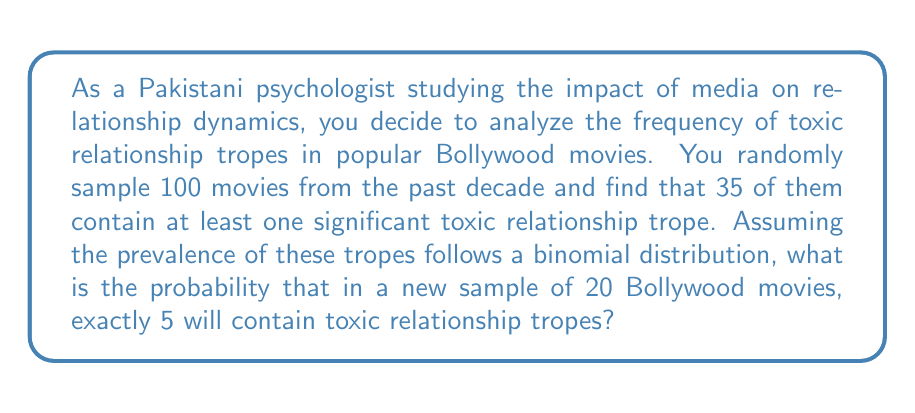Teach me how to tackle this problem. To solve this problem, we need to use the binomial probability distribution formula. The binomial distribution is appropriate here because we have a fixed number of independent trials (watching 20 movies), each with the same probability of success (containing a toxic relationship trope), and we're interested in a specific number of successes.

Let's define our variables:
$n = 20$ (number of movies in the new sample)
$k = 5$ (number of movies we want to contain toxic tropes)
$p = 35/100 = 0.35$ (probability of a movie containing a toxic trope, based on the initial sample)

The binomial probability formula is:

$$P(X = k) = \binom{n}{k} p^k (1-p)^{n-k}$$

Where $\binom{n}{k}$ is the binomial coefficient, calculated as:

$$\binom{n}{k} = \frac{n!}{k!(n-k)!}$$

Let's substitute our values:

$$P(X = 5) = \binom{20}{5} (0.35)^5 (1-0.35)^{20-5}$$

$$= \frac{20!}{5!(20-5)!} (0.35)^5 (0.65)^{15}$$

$$= 15504 \cdot (0.35)^5 \cdot (0.65)^{15}$$

$$= 15504 \cdot 0.0052521875 \cdot 0.0012937241$$

$$= 0.1054$$
Answer: The probability that exactly 5 out of 20 randomly sampled Bollywood movies will contain toxic relationship tropes is approximately 0.1054 or 10.54%. 